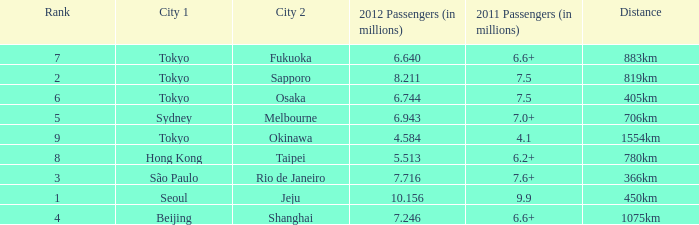Which city is listed first when Okinawa is listed as the second city? Tokyo. 